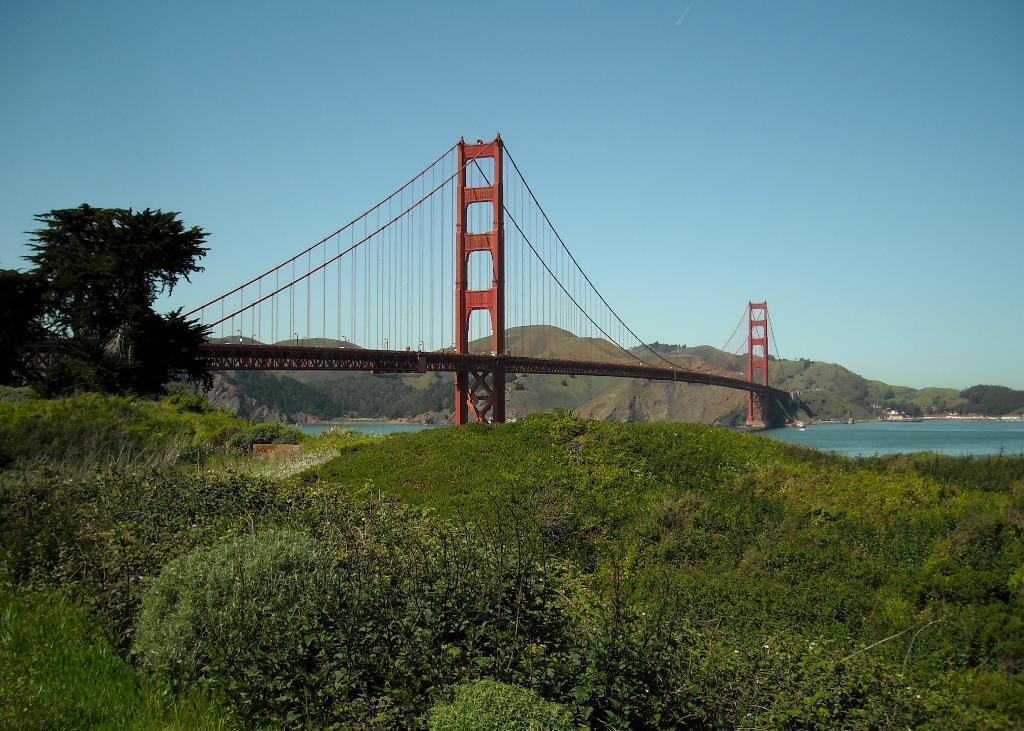Can you describe this image briefly? In the picture we can see, full of plants and near to it, we can see some tree and bridge from one corner to another corner of the hill and in the background we can see a sky. 